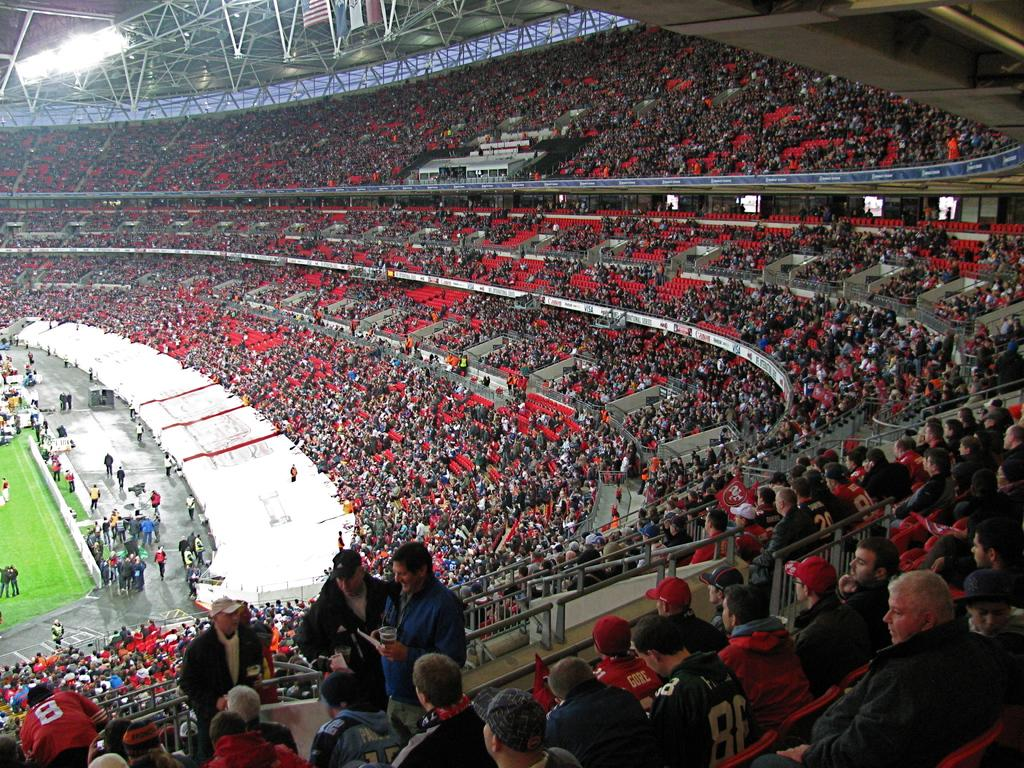What is the main setting of the image? The main setting of the image is a stadium. What can be seen on the ground in the image? There are many people on the ground in the image. What is covering the stadium in the image? There is a roof visible in the image. What can be seen illuminating the stadium? There are lights in the image. What decorative elements are present in the image? There are flags in the image. What type of notebook is being used by the person laughing in the image? There is no person laughing in the image, and no notebook is present. 